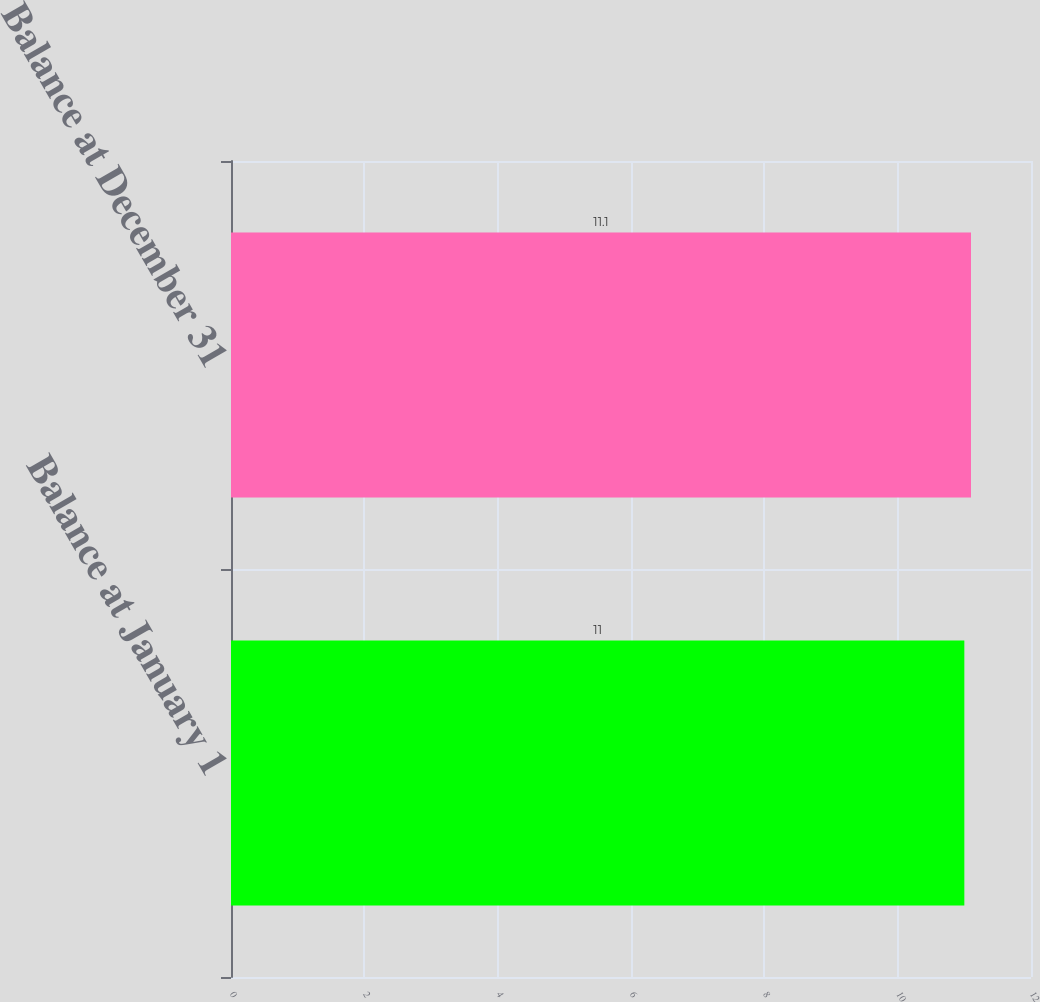Convert chart to OTSL. <chart><loc_0><loc_0><loc_500><loc_500><bar_chart><fcel>Balance at January 1<fcel>Balance at December 31<nl><fcel>11<fcel>11.1<nl></chart> 